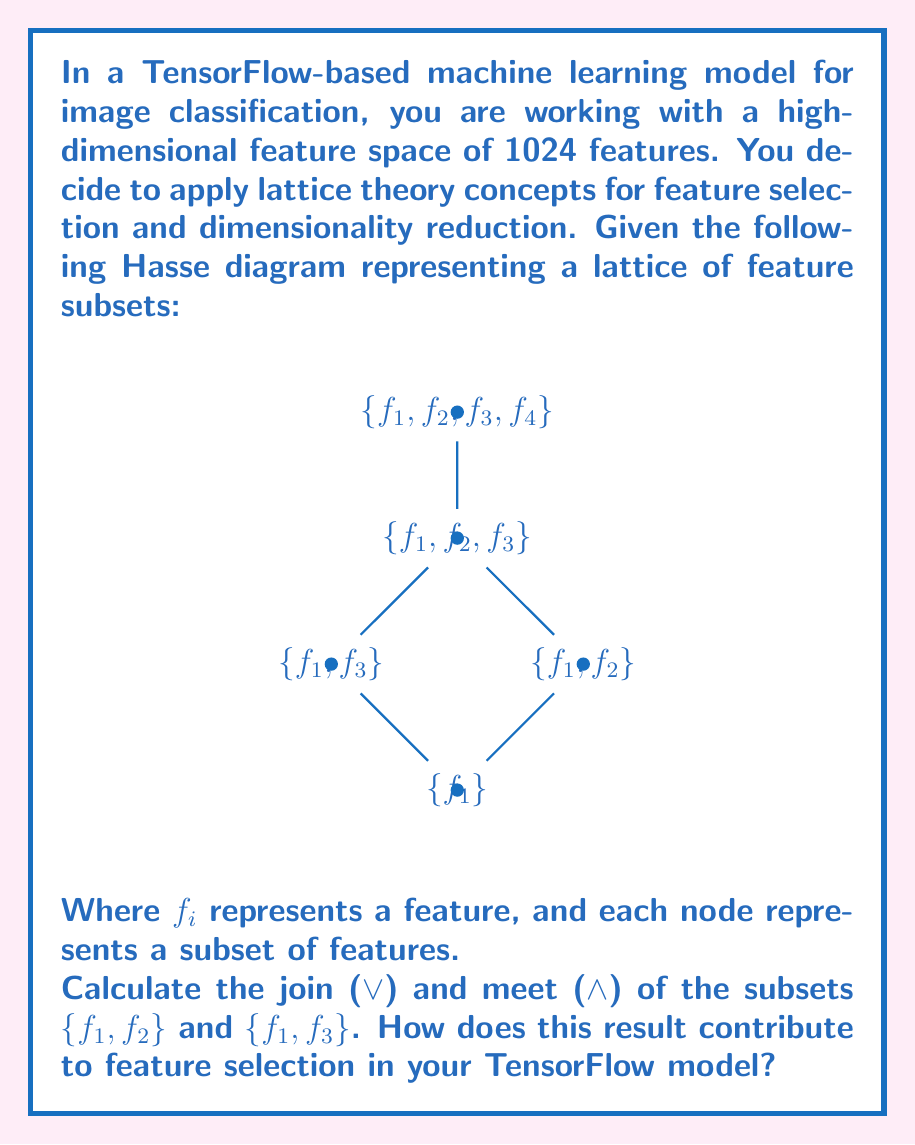Can you answer this question? To solve this problem, let's follow these steps:

1) First, recall that in lattice theory:
   - The join ($\lor$) of two elements is their least upper bound.
   - The meet ($\land$) of two elements is their greatest lower bound.

2) In the context of feature selection, the lattice represents possible feature subsets, where:
   - Moving up the lattice means adding features.
   - Moving down the lattice means removing features.

3) Let's identify the subsets:
   - $A = \{f_1, f_2\}$
   - $B = \{f_1, f_3\}$

4) To find the join ($A \lor B$):
   - We need to find the smallest subset that contains all elements of both $A$ and $B$.
   - This is $\{f_1, f_2, f_3\}$, represented by node $D$ in the diagram.

5) To find the meet ($A \land B$):
   - We need to find the largest subset that is contained in both $A$ and $B$.
   - This is $\{f_1\}$, represented by node $A$ in the diagram.

6) Therefore:
   $\{f_1, f_2\} \lor \{f_1, f_3\} = \{f_1, f_2, f_3\}$
   $\{f_1, f_2\} \land \{f_1, f_3\} = \{f_1\}$

7) In the context of feature selection for a TensorFlow model:
   - The join operation suggests that to capture the information in both feature subsets, we need to use features $f_1$, $f_2$, and $f_3$.
   - The meet operation identifies $f_1$ as the common feature between the two subsets, which might be a crucial feature for the model.

8) This lattice-based approach helps in:
   - Identifying minimal feature sets that capture necessary information (join).
   - Finding common important features across different subsets (meet).
   - Providing a structured way to explore feature combinations, potentially reducing the dimensionality of the input space while preserving important information.

In TensorFlow, this could guide the design of the input layer or feature extraction layers, potentially improving model efficiency and interpretability.
Answer: Join: $\{f_1, f_2, f_3\}$, Meet: $\{f_1\}$. Contributes by identifying minimal informative feature sets and common important features, guiding efficient input layer design in TensorFlow. 